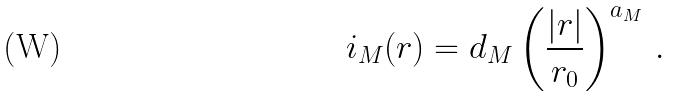Convert formula to latex. <formula><loc_0><loc_0><loc_500><loc_500>i _ { M } ( r ) = d _ { M } \left ( \frac { | r | } { r _ { 0 } } \right ) ^ { a _ { M } } \, .</formula> 